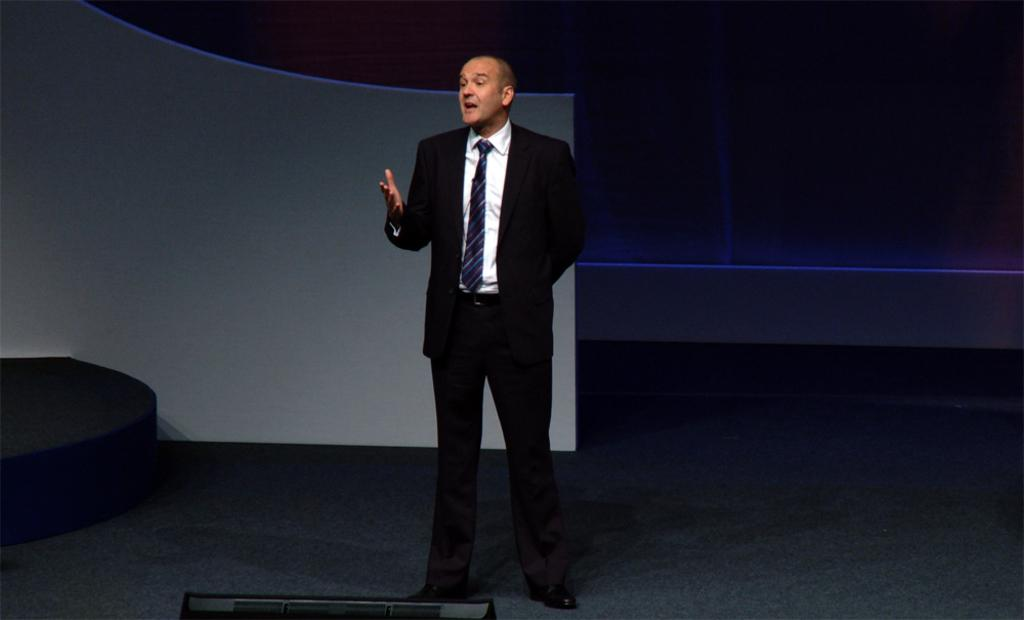Who or what is present in the image? There is a person in the image. What is the person doing in the image? The person is standing. What type of clothing is the person wearing in the image? The person is wearing a blazer. What type of appliance can be seen in the background of the image? There is no appliance visible in the image; it only features a person standing and wearing a blazer. 